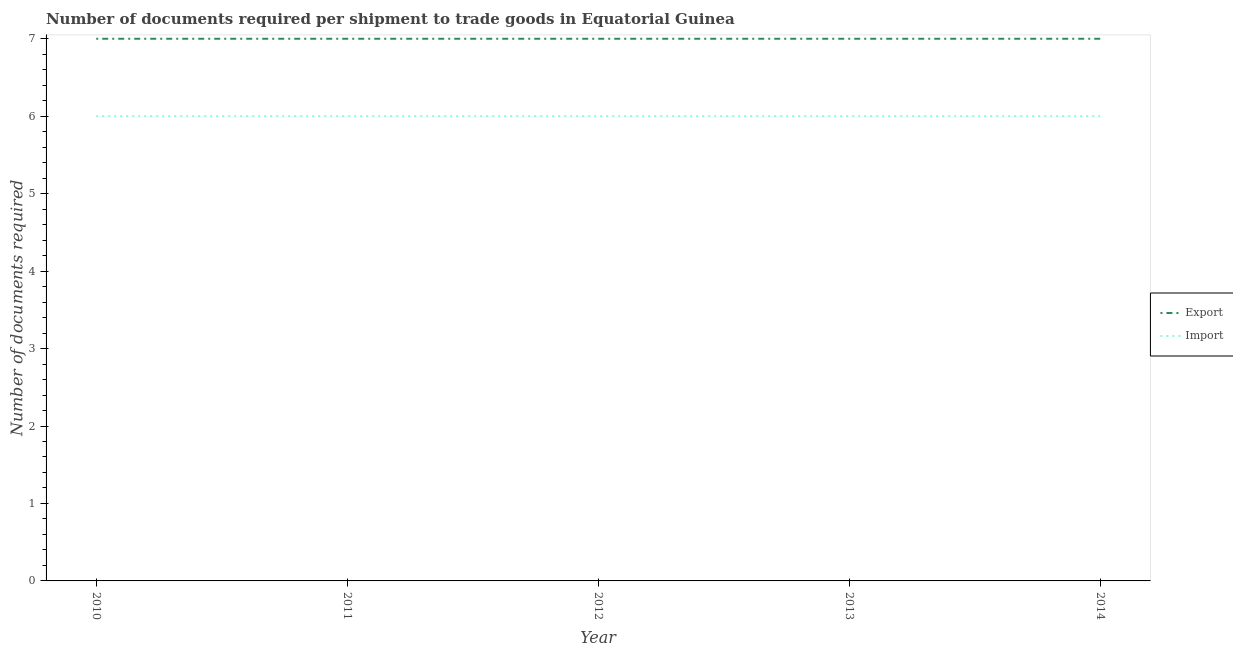What is the number of documents required to import goods in 2013?
Offer a terse response. 6. Across all years, what is the maximum number of documents required to import goods?
Your response must be concise. 6. Across all years, what is the minimum number of documents required to import goods?
Your answer should be very brief. 6. In which year was the number of documents required to export goods minimum?
Your answer should be very brief. 2010. What is the total number of documents required to export goods in the graph?
Your response must be concise. 35. What is the difference between the number of documents required to import goods in 2013 and that in 2014?
Give a very brief answer. 0. What is the difference between the number of documents required to import goods in 2012 and the number of documents required to export goods in 2011?
Your answer should be very brief. -1. In the year 2012, what is the difference between the number of documents required to export goods and number of documents required to import goods?
Ensure brevity in your answer.  1. In how many years, is the number of documents required to export goods greater than 0.4?
Your answer should be compact. 5. What is the ratio of the number of documents required to export goods in 2010 to that in 2013?
Make the answer very short. 1. Is the difference between the number of documents required to export goods in 2012 and 2013 greater than the difference between the number of documents required to import goods in 2012 and 2013?
Ensure brevity in your answer.  No. What is the difference between the highest and the second highest number of documents required to export goods?
Provide a short and direct response. 0. In how many years, is the number of documents required to export goods greater than the average number of documents required to export goods taken over all years?
Your answer should be compact. 0. Does the number of documents required to export goods monotonically increase over the years?
Provide a succinct answer. No. Is the number of documents required to import goods strictly greater than the number of documents required to export goods over the years?
Offer a terse response. No. How many lines are there?
Give a very brief answer. 2. How many years are there in the graph?
Offer a terse response. 5. Are the values on the major ticks of Y-axis written in scientific E-notation?
Your response must be concise. No. Does the graph contain any zero values?
Your answer should be very brief. No. Where does the legend appear in the graph?
Your response must be concise. Center right. What is the title of the graph?
Your answer should be compact. Number of documents required per shipment to trade goods in Equatorial Guinea. What is the label or title of the X-axis?
Keep it short and to the point. Year. What is the label or title of the Y-axis?
Keep it short and to the point. Number of documents required. What is the Number of documents required of Import in 2010?
Provide a short and direct response. 6. What is the Number of documents required in Export in 2013?
Your response must be concise. 7. What is the Number of documents required of Import in 2013?
Make the answer very short. 6. What is the Number of documents required of Export in 2014?
Give a very brief answer. 7. Across all years, what is the maximum Number of documents required of Export?
Offer a very short reply. 7. Across all years, what is the maximum Number of documents required of Import?
Your answer should be compact. 6. What is the total Number of documents required in Import in the graph?
Your response must be concise. 30. What is the difference between the Number of documents required of Export in 2010 and that in 2011?
Make the answer very short. 0. What is the difference between the Number of documents required in Import in 2010 and that in 2011?
Your answer should be compact. 0. What is the difference between the Number of documents required of Export in 2011 and that in 2013?
Provide a short and direct response. 0. What is the difference between the Number of documents required of Import in 2011 and that in 2014?
Your response must be concise. 0. What is the difference between the Number of documents required in Import in 2012 and that in 2013?
Keep it short and to the point. 0. What is the difference between the Number of documents required in Import in 2013 and that in 2014?
Your answer should be very brief. 0. What is the difference between the Number of documents required in Export in 2010 and the Number of documents required in Import in 2011?
Make the answer very short. 1. What is the difference between the Number of documents required in Export in 2010 and the Number of documents required in Import in 2013?
Provide a short and direct response. 1. What is the difference between the Number of documents required of Export in 2010 and the Number of documents required of Import in 2014?
Provide a short and direct response. 1. What is the difference between the Number of documents required in Export in 2011 and the Number of documents required in Import in 2012?
Provide a short and direct response. 1. What is the difference between the Number of documents required of Export in 2012 and the Number of documents required of Import in 2013?
Give a very brief answer. 1. What is the difference between the Number of documents required of Export in 2012 and the Number of documents required of Import in 2014?
Offer a terse response. 1. What is the difference between the Number of documents required in Export in 2013 and the Number of documents required in Import in 2014?
Your answer should be very brief. 1. What is the average Number of documents required in Import per year?
Give a very brief answer. 6. In the year 2010, what is the difference between the Number of documents required of Export and Number of documents required of Import?
Offer a terse response. 1. In the year 2011, what is the difference between the Number of documents required in Export and Number of documents required in Import?
Keep it short and to the point. 1. In the year 2012, what is the difference between the Number of documents required in Export and Number of documents required in Import?
Your answer should be very brief. 1. What is the ratio of the Number of documents required of Export in 2010 to that in 2011?
Keep it short and to the point. 1. What is the ratio of the Number of documents required of Import in 2010 to that in 2011?
Ensure brevity in your answer.  1. What is the ratio of the Number of documents required in Export in 2010 to that in 2012?
Offer a very short reply. 1. What is the ratio of the Number of documents required in Export in 2010 to that in 2014?
Your answer should be very brief. 1. What is the ratio of the Number of documents required in Import in 2011 to that in 2012?
Make the answer very short. 1. What is the ratio of the Number of documents required of Export in 2011 to that in 2013?
Your response must be concise. 1. What is the ratio of the Number of documents required of Export in 2011 to that in 2014?
Give a very brief answer. 1. What is the ratio of the Number of documents required in Import in 2011 to that in 2014?
Provide a short and direct response. 1. What is the ratio of the Number of documents required in Import in 2012 to that in 2013?
Provide a short and direct response. 1. What is the ratio of the Number of documents required of Export in 2012 to that in 2014?
Provide a succinct answer. 1. What is the ratio of the Number of documents required in Import in 2012 to that in 2014?
Offer a terse response. 1. What is the ratio of the Number of documents required in Export in 2013 to that in 2014?
Your response must be concise. 1. What is the ratio of the Number of documents required of Import in 2013 to that in 2014?
Your answer should be compact. 1. What is the difference between the highest and the second highest Number of documents required in Export?
Ensure brevity in your answer.  0. What is the difference between the highest and the lowest Number of documents required in Import?
Offer a very short reply. 0. 